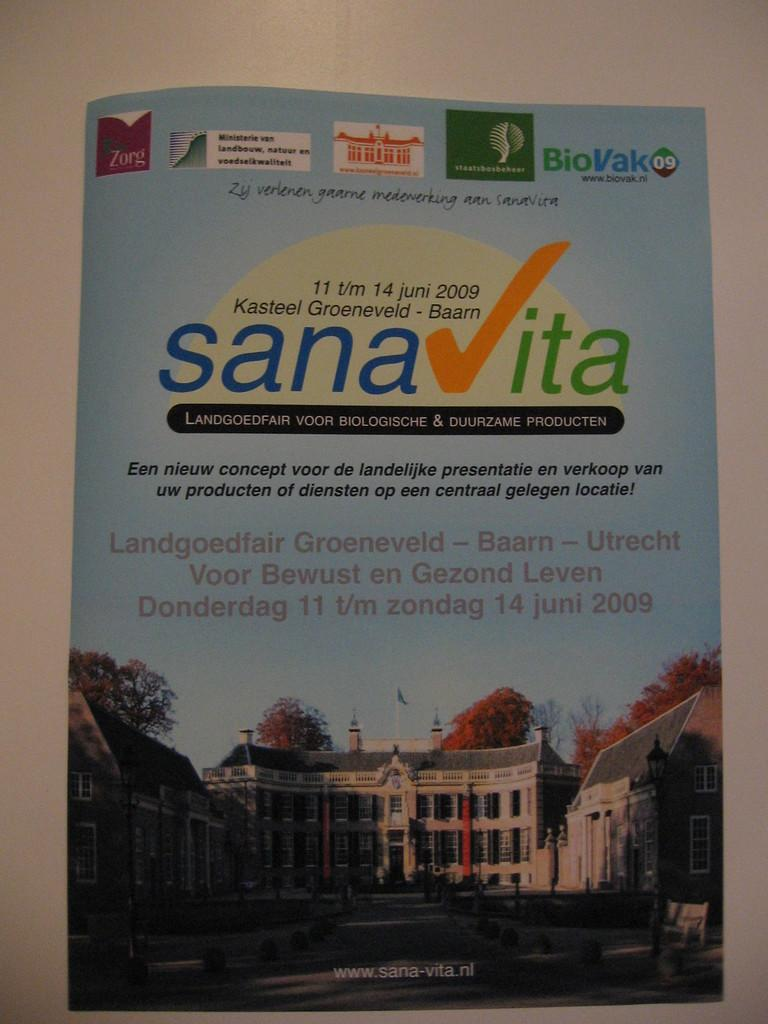<image>
Describe the image concisely. a poster with a building on it and a date of 2009 